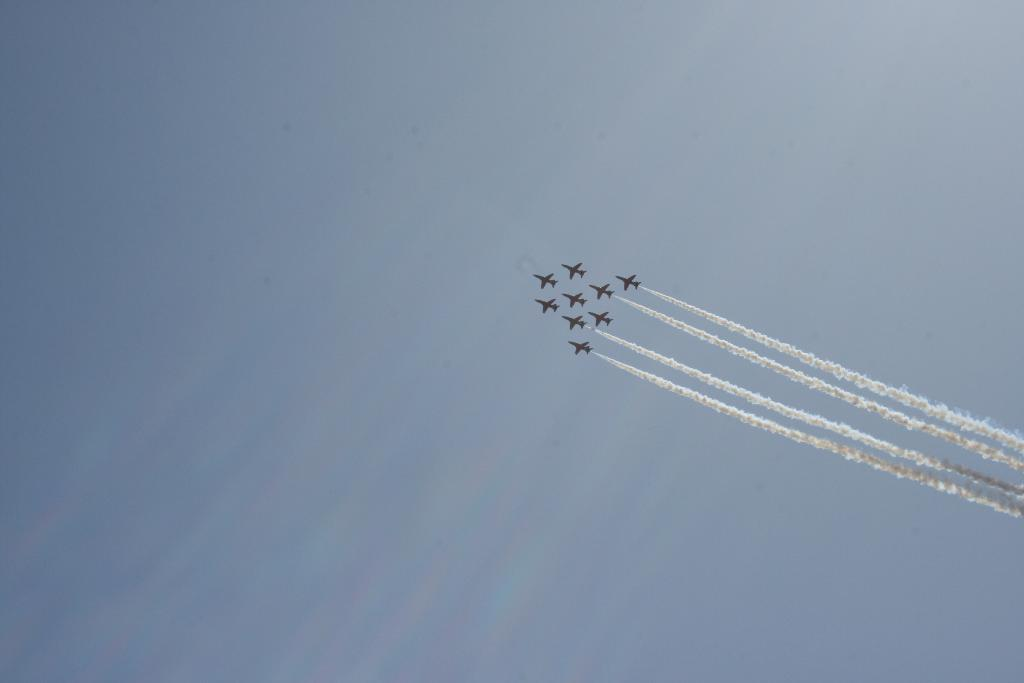What is the main subject of the image? The main subject of the image is airplanes. What can be seen in the air around the airplanes? There is smoke in the air. What part of the natural environment is visible in the image? The sky is visible in the image. What type of love songs can be heard playing in the background of the image? There is no indication of any music or songs in the image, so it cannot be determined what type of love songs might be heard. 